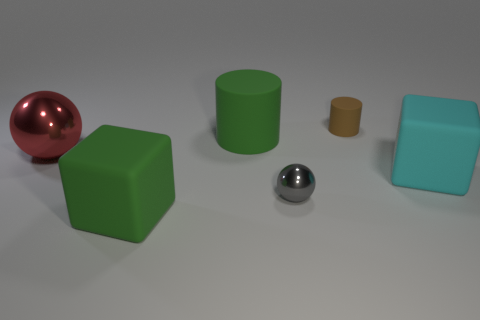Add 1 big matte things. How many objects exist? 7 Subtract all cylinders. How many objects are left? 4 Subtract all tiny green balls. Subtract all rubber objects. How many objects are left? 2 Add 2 large things. How many large things are left? 6 Add 1 cyan rubber things. How many cyan rubber things exist? 2 Subtract 0 red blocks. How many objects are left? 6 